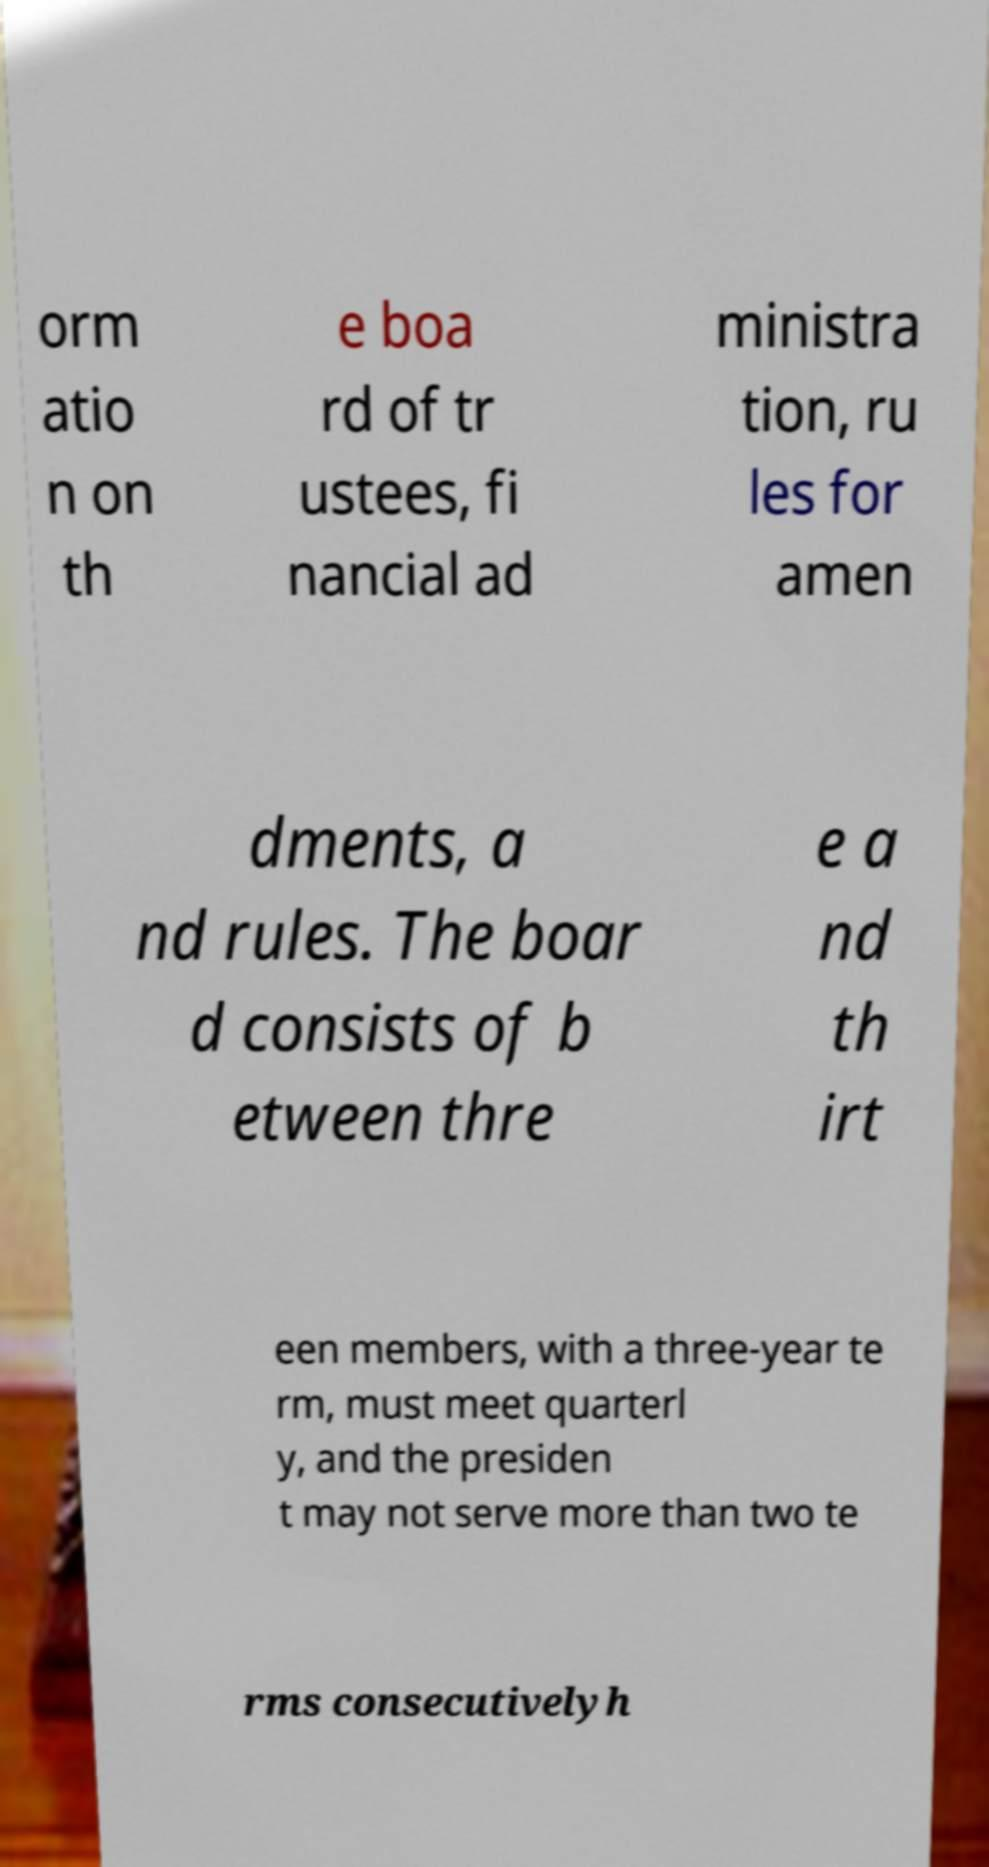Can you read and provide the text displayed in the image?This photo seems to have some interesting text. Can you extract and type it out for me? orm atio n on th e boa rd of tr ustees, fi nancial ad ministra tion, ru les for amen dments, a nd rules. The boar d consists of b etween thre e a nd th irt een members, with a three-year te rm, must meet quarterl y, and the presiden t may not serve more than two te rms consecutivelyh 